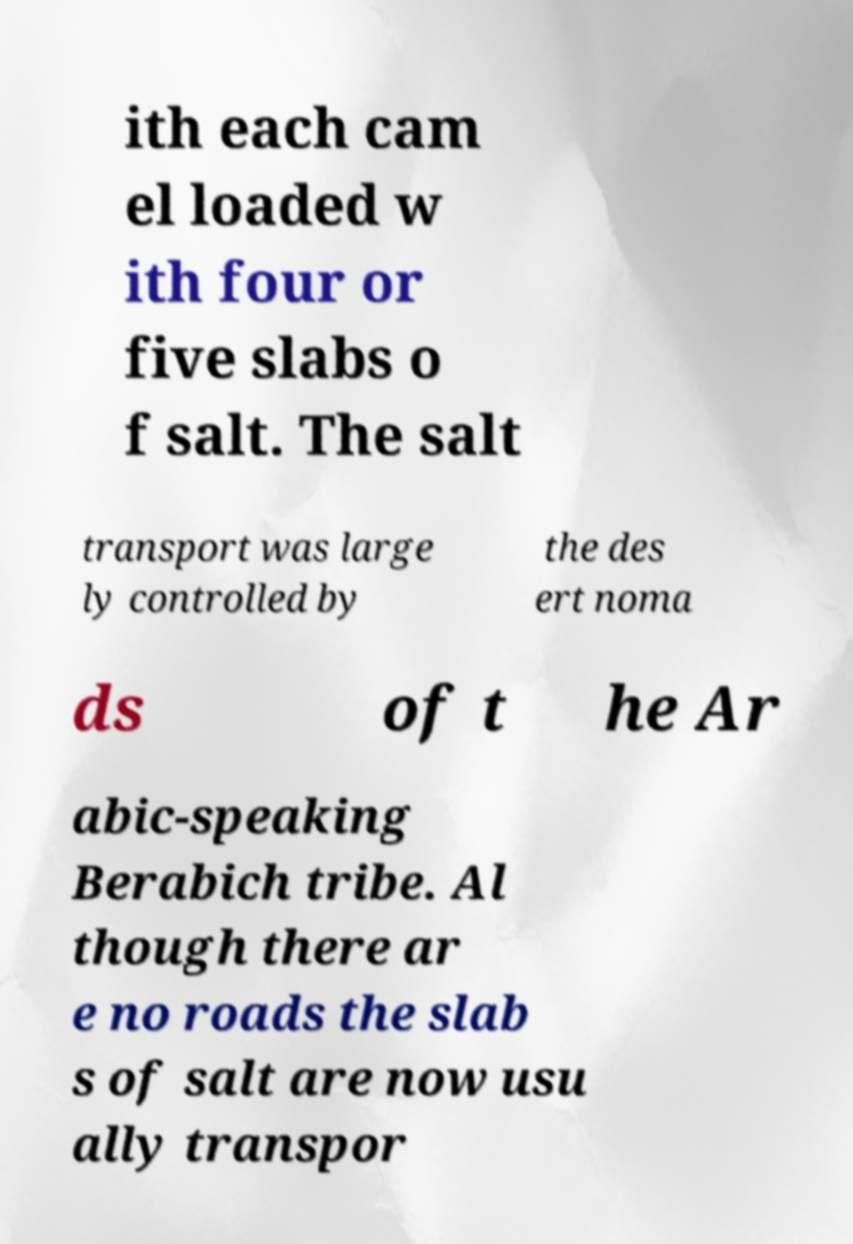Please identify and transcribe the text found in this image. ith each cam el loaded w ith four or five slabs o f salt. The salt transport was large ly controlled by the des ert noma ds of t he Ar abic-speaking Berabich tribe. Al though there ar e no roads the slab s of salt are now usu ally transpor 